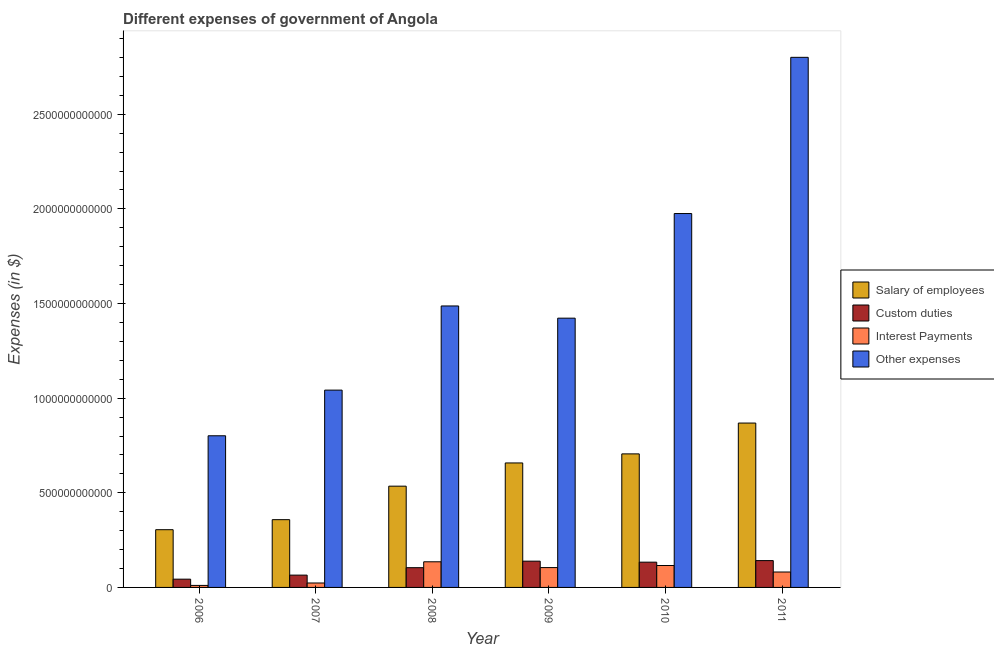How many different coloured bars are there?
Offer a very short reply. 4. Are the number of bars per tick equal to the number of legend labels?
Your answer should be very brief. Yes. Are the number of bars on each tick of the X-axis equal?
Your answer should be very brief. Yes. How many bars are there on the 6th tick from the left?
Provide a succinct answer. 4. What is the amount spent on other expenses in 2010?
Keep it short and to the point. 1.98e+12. Across all years, what is the maximum amount spent on custom duties?
Keep it short and to the point. 1.42e+11. Across all years, what is the minimum amount spent on other expenses?
Offer a very short reply. 8.01e+11. In which year was the amount spent on interest payments maximum?
Offer a terse response. 2008. What is the total amount spent on custom duties in the graph?
Offer a terse response. 6.27e+11. What is the difference between the amount spent on interest payments in 2006 and that in 2011?
Make the answer very short. -7.08e+1. What is the difference between the amount spent on other expenses in 2010 and the amount spent on custom duties in 2007?
Ensure brevity in your answer.  9.33e+11. What is the average amount spent on custom duties per year?
Make the answer very short. 1.04e+11. In how many years, is the amount spent on other expenses greater than 2100000000000 $?
Provide a short and direct response. 1. What is the ratio of the amount spent on interest payments in 2006 to that in 2009?
Your response must be concise. 0.1. Is the amount spent on custom duties in 2006 less than that in 2011?
Provide a succinct answer. Yes. What is the difference between the highest and the second highest amount spent on salary of employees?
Keep it short and to the point. 1.63e+11. What is the difference between the highest and the lowest amount spent on custom duties?
Make the answer very short. 9.81e+1. In how many years, is the amount spent on custom duties greater than the average amount spent on custom duties taken over all years?
Give a very brief answer. 3. Is the sum of the amount spent on custom duties in 2006 and 2007 greater than the maximum amount spent on other expenses across all years?
Provide a succinct answer. No. Is it the case that in every year, the sum of the amount spent on custom duties and amount spent on salary of employees is greater than the sum of amount spent on other expenses and amount spent on interest payments?
Make the answer very short. No. What does the 3rd bar from the left in 2006 represents?
Give a very brief answer. Interest Payments. What does the 2nd bar from the right in 2006 represents?
Ensure brevity in your answer.  Interest Payments. Is it the case that in every year, the sum of the amount spent on salary of employees and amount spent on custom duties is greater than the amount spent on interest payments?
Your response must be concise. Yes. How many bars are there?
Provide a short and direct response. 24. Are all the bars in the graph horizontal?
Ensure brevity in your answer.  No. What is the difference between two consecutive major ticks on the Y-axis?
Make the answer very short. 5.00e+11. Are the values on the major ticks of Y-axis written in scientific E-notation?
Your answer should be compact. No. Does the graph contain any zero values?
Provide a short and direct response. No. Where does the legend appear in the graph?
Provide a short and direct response. Center right. How are the legend labels stacked?
Keep it short and to the point. Vertical. What is the title of the graph?
Your answer should be compact. Different expenses of government of Angola. Does "UNDP" appear as one of the legend labels in the graph?
Offer a very short reply. No. What is the label or title of the Y-axis?
Your answer should be compact. Expenses (in $). What is the Expenses (in $) in Salary of employees in 2006?
Give a very brief answer. 3.05e+11. What is the Expenses (in $) in Custom duties in 2006?
Ensure brevity in your answer.  4.37e+1. What is the Expenses (in $) of Interest Payments in 2006?
Make the answer very short. 1.07e+1. What is the Expenses (in $) of Other expenses in 2006?
Keep it short and to the point. 8.01e+11. What is the Expenses (in $) in Salary of employees in 2007?
Offer a very short reply. 3.58e+11. What is the Expenses (in $) in Custom duties in 2007?
Ensure brevity in your answer.  6.50e+1. What is the Expenses (in $) of Interest Payments in 2007?
Keep it short and to the point. 2.35e+1. What is the Expenses (in $) of Other expenses in 2007?
Your answer should be compact. 1.04e+12. What is the Expenses (in $) of Salary of employees in 2008?
Offer a terse response. 5.35e+11. What is the Expenses (in $) in Custom duties in 2008?
Your answer should be compact. 1.04e+11. What is the Expenses (in $) of Interest Payments in 2008?
Your answer should be compact. 1.35e+11. What is the Expenses (in $) of Other expenses in 2008?
Your answer should be compact. 1.49e+12. What is the Expenses (in $) in Salary of employees in 2009?
Offer a terse response. 6.58e+11. What is the Expenses (in $) of Custom duties in 2009?
Offer a terse response. 1.39e+11. What is the Expenses (in $) in Interest Payments in 2009?
Your answer should be very brief. 1.05e+11. What is the Expenses (in $) in Other expenses in 2009?
Ensure brevity in your answer.  1.42e+12. What is the Expenses (in $) in Salary of employees in 2010?
Keep it short and to the point. 7.06e+11. What is the Expenses (in $) of Custom duties in 2010?
Make the answer very short. 1.33e+11. What is the Expenses (in $) of Interest Payments in 2010?
Give a very brief answer. 1.16e+11. What is the Expenses (in $) of Other expenses in 2010?
Keep it short and to the point. 1.98e+12. What is the Expenses (in $) in Salary of employees in 2011?
Offer a very short reply. 8.68e+11. What is the Expenses (in $) of Custom duties in 2011?
Your answer should be very brief. 1.42e+11. What is the Expenses (in $) of Interest Payments in 2011?
Give a very brief answer. 8.15e+1. What is the Expenses (in $) in Other expenses in 2011?
Provide a short and direct response. 2.80e+12. Across all years, what is the maximum Expenses (in $) in Salary of employees?
Provide a succinct answer. 8.68e+11. Across all years, what is the maximum Expenses (in $) of Custom duties?
Offer a very short reply. 1.42e+11. Across all years, what is the maximum Expenses (in $) of Interest Payments?
Keep it short and to the point. 1.35e+11. Across all years, what is the maximum Expenses (in $) in Other expenses?
Give a very brief answer. 2.80e+12. Across all years, what is the minimum Expenses (in $) of Salary of employees?
Make the answer very short. 3.05e+11. Across all years, what is the minimum Expenses (in $) of Custom duties?
Your response must be concise. 4.37e+1. Across all years, what is the minimum Expenses (in $) in Interest Payments?
Keep it short and to the point. 1.07e+1. Across all years, what is the minimum Expenses (in $) in Other expenses?
Provide a short and direct response. 8.01e+11. What is the total Expenses (in $) in Salary of employees in the graph?
Provide a short and direct response. 3.43e+12. What is the total Expenses (in $) in Custom duties in the graph?
Your answer should be very brief. 6.27e+11. What is the total Expenses (in $) in Interest Payments in the graph?
Your answer should be very brief. 4.72e+11. What is the total Expenses (in $) of Other expenses in the graph?
Offer a very short reply. 9.53e+12. What is the difference between the Expenses (in $) in Salary of employees in 2006 and that in 2007?
Your response must be concise. -5.30e+1. What is the difference between the Expenses (in $) of Custom duties in 2006 and that in 2007?
Ensure brevity in your answer.  -2.13e+1. What is the difference between the Expenses (in $) of Interest Payments in 2006 and that in 2007?
Ensure brevity in your answer.  -1.28e+1. What is the difference between the Expenses (in $) in Other expenses in 2006 and that in 2007?
Your answer should be very brief. -2.41e+11. What is the difference between the Expenses (in $) in Salary of employees in 2006 and that in 2008?
Your answer should be compact. -2.30e+11. What is the difference between the Expenses (in $) of Custom duties in 2006 and that in 2008?
Give a very brief answer. -6.06e+1. What is the difference between the Expenses (in $) of Interest Payments in 2006 and that in 2008?
Your answer should be very brief. -1.25e+11. What is the difference between the Expenses (in $) in Other expenses in 2006 and that in 2008?
Your answer should be compact. -6.86e+11. What is the difference between the Expenses (in $) of Salary of employees in 2006 and that in 2009?
Provide a succinct answer. -3.53e+11. What is the difference between the Expenses (in $) of Custom duties in 2006 and that in 2009?
Make the answer very short. -9.51e+1. What is the difference between the Expenses (in $) of Interest Payments in 2006 and that in 2009?
Your response must be concise. -9.41e+1. What is the difference between the Expenses (in $) in Other expenses in 2006 and that in 2009?
Give a very brief answer. -6.21e+11. What is the difference between the Expenses (in $) of Salary of employees in 2006 and that in 2010?
Keep it short and to the point. -4.01e+11. What is the difference between the Expenses (in $) in Custom duties in 2006 and that in 2010?
Your response must be concise. -8.98e+1. What is the difference between the Expenses (in $) of Interest Payments in 2006 and that in 2010?
Your answer should be compact. -1.05e+11. What is the difference between the Expenses (in $) in Other expenses in 2006 and that in 2010?
Ensure brevity in your answer.  -1.17e+12. What is the difference between the Expenses (in $) of Salary of employees in 2006 and that in 2011?
Your answer should be compact. -5.63e+11. What is the difference between the Expenses (in $) in Custom duties in 2006 and that in 2011?
Your response must be concise. -9.81e+1. What is the difference between the Expenses (in $) of Interest Payments in 2006 and that in 2011?
Ensure brevity in your answer.  -7.08e+1. What is the difference between the Expenses (in $) of Other expenses in 2006 and that in 2011?
Offer a terse response. -2.00e+12. What is the difference between the Expenses (in $) in Salary of employees in 2007 and that in 2008?
Provide a succinct answer. -1.77e+11. What is the difference between the Expenses (in $) of Custom duties in 2007 and that in 2008?
Your answer should be very brief. -3.93e+1. What is the difference between the Expenses (in $) in Interest Payments in 2007 and that in 2008?
Your answer should be compact. -1.12e+11. What is the difference between the Expenses (in $) of Other expenses in 2007 and that in 2008?
Offer a terse response. -4.45e+11. What is the difference between the Expenses (in $) in Salary of employees in 2007 and that in 2009?
Offer a terse response. -3.00e+11. What is the difference between the Expenses (in $) of Custom duties in 2007 and that in 2009?
Provide a short and direct response. -7.38e+1. What is the difference between the Expenses (in $) of Interest Payments in 2007 and that in 2009?
Offer a terse response. -8.13e+1. What is the difference between the Expenses (in $) of Other expenses in 2007 and that in 2009?
Offer a terse response. -3.80e+11. What is the difference between the Expenses (in $) of Salary of employees in 2007 and that in 2010?
Your answer should be very brief. -3.48e+11. What is the difference between the Expenses (in $) of Custom duties in 2007 and that in 2010?
Your answer should be compact. -6.84e+1. What is the difference between the Expenses (in $) of Interest Payments in 2007 and that in 2010?
Give a very brief answer. -9.24e+1. What is the difference between the Expenses (in $) of Other expenses in 2007 and that in 2010?
Provide a short and direct response. -9.33e+11. What is the difference between the Expenses (in $) in Salary of employees in 2007 and that in 2011?
Your answer should be very brief. -5.10e+11. What is the difference between the Expenses (in $) in Custom duties in 2007 and that in 2011?
Your answer should be very brief. -7.67e+1. What is the difference between the Expenses (in $) of Interest Payments in 2007 and that in 2011?
Keep it short and to the point. -5.80e+1. What is the difference between the Expenses (in $) of Other expenses in 2007 and that in 2011?
Make the answer very short. -1.76e+12. What is the difference between the Expenses (in $) in Salary of employees in 2008 and that in 2009?
Your answer should be very brief. -1.23e+11. What is the difference between the Expenses (in $) of Custom duties in 2008 and that in 2009?
Ensure brevity in your answer.  -3.45e+1. What is the difference between the Expenses (in $) in Interest Payments in 2008 and that in 2009?
Your answer should be compact. 3.07e+1. What is the difference between the Expenses (in $) of Other expenses in 2008 and that in 2009?
Provide a succinct answer. 6.45e+1. What is the difference between the Expenses (in $) in Salary of employees in 2008 and that in 2010?
Provide a succinct answer. -1.71e+11. What is the difference between the Expenses (in $) of Custom duties in 2008 and that in 2010?
Keep it short and to the point. -2.92e+1. What is the difference between the Expenses (in $) in Interest Payments in 2008 and that in 2010?
Your answer should be very brief. 1.96e+1. What is the difference between the Expenses (in $) in Other expenses in 2008 and that in 2010?
Ensure brevity in your answer.  -4.88e+11. What is the difference between the Expenses (in $) in Salary of employees in 2008 and that in 2011?
Offer a terse response. -3.33e+11. What is the difference between the Expenses (in $) in Custom duties in 2008 and that in 2011?
Offer a very short reply. -3.74e+1. What is the difference between the Expenses (in $) in Interest Payments in 2008 and that in 2011?
Ensure brevity in your answer.  5.40e+1. What is the difference between the Expenses (in $) in Other expenses in 2008 and that in 2011?
Offer a very short reply. -1.31e+12. What is the difference between the Expenses (in $) in Salary of employees in 2009 and that in 2010?
Offer a very short reply. -4.79e+1. What is the difference between the Expenses (in $) in Custom duties in 2009 and that in 2010?
Provide a succinct answer. 5.33e+09. What is the difference between the Expenses (in $) in Interest Payments in 2009 and that in 2010?
Offer a terse response. -1.10e+1. What is the difference between the Expenses (in $) in Other expenses in 2009 and that in 2010?
Ensure brevity in your answer.  -5.53e+11. What is the difference between the Expenses (in $) in Salary of employees in 2009 and that in 2011?
Ensure brevity in your answer.  -2.11e+11. What is the difference between the Expenses (in $) of Custom duties in 2009 and that in 2011?
Keep it short and to the point. -2.95e+09. What is the difference between the Expenses (in $) of Interest Payments in 2009 and that in 2011?
Ensure brevity in your answer.  2.33e+1. What is the difference between the Expenses (in $) of Other expenses in 2009 and that in 2011?
Offer a very short reply. -1.38e+12. What is the difference between the Expenses (in $) of Salary of employees in 2010 and that in 2011?
Make the answer very short. -1.63e+11. What is the difference between the Expenses (in $) of Custom duties in 2010 and that in 2011?
Offer a very short reply. -8.27e+09. What is the difference between the Expenses (in $) of Interest Payments in 2010 and that in 2011?
Your answer should be very brief. 3.44e+1. What is the difference between the Expenses (in $) in Other expenses in 2010 and that in 2011?
Keep it short and to the point. -8.25e+11. What is the difference between the Expenses (in $) in Salary of employees in 2006 and the Expenses (in $) in Custom duties in 2007?
Your answer should be very brief. 2.40e+11. What is the difference between the Expenses (in $) of Salary of employees in 2006 and the Expenses (in $) of Interest Payments in 2007?
Ensure brevity in your answer.  2.82e+11. What is the difference between the Expenses (in $) of Salary of employees in 2006 and the Expenses (in $) of Other expenses in 2007?
Ensure brevity in your answer.  -7.37e+11. What is the difference between the Expenses (in $) of Custom duties in 2006 and the Expenses (in $) of Interest Payments in 2007?
Provide a short and direct response. 2.02e+1. What is the difference between the Expenses (in $) in Custom duties in 2006 and the Expenses (in $) in Other expenses in 2007?
Your answer should be very brief. -9.99e+11. What is the difference between the Expenses (in $) of Interest Payments in 2006 and the Expenses (in $) of Other expenses in 2007?
Make the answer very short. -1.03e+12. What is the difference between the Expenses (in $) of Salary of employees in 2006 and the Expenses (in $) of Custom duties in 2008?
Your answer should be very brief. 2.01e+11. What is the difference between the Expenses (in $) of Salary of employees in 2006 and the Expenses (in $) of Interest Payments in 2008?
Provide a short and direct response. 1.70e+11. What is the difference between the Expenses (in $) in Salary of employees in 2006 and the Expenses (in $) in Other expenses in 2008?
Offer a terse response. -1.18e+12. What is the difference between the Expenses (in $) in Custom duties in 2006 and the Expenses (in $) in Interest Payments in 2008?
Provide a succinct answer. -9.18e+1. What is the difference between the Expenses (in $) of Custom duties in 2006 and the Expenses (in $) of Other expenses in 2008?
Provide a short and direct response. -1.44e+12. What is the difference between the Expenses (in $) of Interest Payments in 2006 and the Expenses (in $) of Other expenses in 2008?
Provide a short and direct response. -1.48e+12. What is the difference between the Expenses (in $) in Salary of employees in 2006 and the Expenses (in $) in Custom duties in 2009?
Ensure brevity in your answer.  1.66e+11. What is the difference between the Expenses (in $) of Salary of employees in 2006 and the Expenses (in $) of Interest Payments in 2009?
Make the answer very short. 2.00e+11. What is the difference between the Expenses (in $) in Salary of employees in 2006 and the Expenses (in $) in Other expenses in 2009?
Ensure brevity in your answer.  -1.12e+12. What is the difference between the Expenses (in $) in Custom duties in 2006 and the Expenses (in $) in Interest Payments in 2009?
Ensure brevity in your answer.  -6.11e+1. What is the difference between the Expenses (in $) in Custom duties in 2006 and the Expenses (in $) in Other expenses in 2009?
Ensure brevity in your answer.  -1.38e+12. What is the difference between the Expenses (in $) in Interest Payments in 2006 and the Expenses (in $) in Other expenses in 2009?
Your answer should be very brief. -1.41e+12. What is the difference between the Expenses (in $) in Salary of employees in 2006 and the Expenses (in $) in Custom duties in 2010?
Your answer should be compact. 1.72e+11. What is the difference between the Expenses (in $) in Salary of employees in 2006 and the Expenses (in $) in Interest Payments in 2010?
Give a very brief answer. 1.89e+11. What is the difference between the Expenses (in $) in Salary of employees in 2006 and the Expenses (in $) in Other expenses in 2010?
Provide a short and direct response. -1.67e+12. What is the difference between the Expenses (in $) of Custom duties in 2006 and the Expenses (in $) of Interest Payments in 2010?
Your answer should be very brief. -7.22e+1. What is the difference between the Expenses (in $) in Custom duties in 2006 and the Expenses (in $) in Other expenses in 2010?
Make the answer very short. -1.93e+12. What is the difference between the Expenses (in $) of Interest Payments in 2006 and the Expenses (in $) of Other expenses in 2010?
Provide a short and direct response. -1.96e+12. What is the difference between the Expenses (in $) in Salary of employees in 2006 and the Expenses (in $) in Custom duties in 2011?
Your answer should be very brief. 1.63e+11. What is the difference between the Expenses (in $) of Salary of employees in 2006 and the Expenses (in $) of Interest Payments in 2011?
Ensure brevity in your answer.  2.24e+11. What is the difference between the Expenses (in $) of Salary of employees in 2006 and the Expenses (in $) of Other expenses in 2011?
Keep it short and to the point. -2.50e+12. What is the difference between the Expenses (in $) of Custom duties in 2006 and the Expenses (in $) of Interest Payments in 2011?
Your answer should be very brief. -3.78e+1. What is the difference between the Expenses (in $) of Custom duties in 2006 and the Expenses (in $) of Other expenses in 2011?
Your answer should be very brief. -2.76e+12. What is the difference between the Expenses (in $) in Interest Payments in 2006 and the Expenses (in $) in Other expenses in 2011?
Keep it short and to the point. -2.79e+12. What is the difference between the Expenses (in $) in Salary of employees in 2007 and the Expenses (in $) in Custom duties in 2008?
Provide a succinct answer. 2.54e+11. What is the difference between the Expenses (in $) in Salary of employees in 2007 and the Expenses (in $) in Interest Payments in 2008?
Keep it short and to the point. 2.23e+11. What is the difference between the Expenses (in $) of Salary of employees in 2007 and the Expenses (in $) of Other expenses in 2008?
Provide a short and direct response. -1.13e+12. What is the difference between the Expenses (in $) of Custom duties in 2007 and the Expenses (in $) of Interest Payments in 2008?
Offer a very short reply. -7.05e+1. What is the difference between the Expenses (in $) of Custom duties in 2007 and the Expenses (in $) of Other expenses in 2008?
Make the answer very short. -1.42e+12. What is the difference between the Expenses (in $) in Interest Payments in 2007 and the Expenses (in $) in Other expenses in 2008?
Offer a very short reply. -1.46e+12. What is the difference between the Expenses (in $) of Salary of employees in 2007 and the Expenses (in $) of Custom duties in 2009?
Keep it short and to the point. 2.19e+11. What is the difference between the Expenses (in $) in Salary of employees in 2007 and the Expenses (in $) in Interest Payments in 2009?
Provide a succinct answer. 2.53e+11. What is the difference between the Expenses (in $) in Salary of employees in 2007 and the Expenses (in $) in Other expenses in 2009?
Your answer should be compact. -1.06e+12. What is the difference between the Expenses (in $) of Custom duties in 2007 and the Expenses (in $) of Interest Payments in 2009?
Offer a terse response. -3.98e+1. What is the difference between the Expenses (in $) in Custom duties in 2007 and the Expenses (in $) in Other expenses in 2009?
Make the answer very short. -1.36e+12. What is the difference between the Expenses (in $) of Interest Payments in 2007 and the Expenses (in $) of Other expenses in 2009?
Keep it short and to the point. -1.40e+12. What is the difference between the Expenses (in $) in Salary of employees in 2007 and the Expenses (in $) in Custom duties in 2010?
Keep it short and to the point. 2.25e+11. What is the difference between the Expenses (in $) in Salary of employees in 2007 and the Expenses (in $) in Interest Payments in 2010?
Keep it short and to the point. 2.42e+11. What is the difference between the Expenses (in $) of Salary of employees in 2007 and the Expenses (in $) of Other expenses in 2010?
Offer a very short reply. -1.62e+12. What is the difference between the Expenses (in $) in Custom duties in 2007 and the Expenses (in $) in Interest Payments in 2010?
Offer a very short reply. -5.08e+1. What is the difference between the Expenses (in $) of Custom duties in 2007 and the Expenses (in $) of Other expenses in 2010?
Your answer should be compact. -1.91e+12. What is the difference between the Expenses (in $) of Interest Payments in 2007 and the Expenses (in $) of Other expenses in 2010?
Offer a very short reply. -1.95e+12. What is the difference between the Expenses (in $) of Salary of employees in 2007 and the Expenses (in $) of Custom duties in 2011?
Offer a very short reply. 2.16e+11. What is the difference between the Expenses (in $) in Salary of employees in 2007 and the Expenses (in $) in Interest Payments in 2011?
Offer a very short reply. 2.77e+11. What is the difference between the Expenses (in $) of Salary of employees in 2007 and the Expenses (in $) of Other expenses in 2011?
Your response must be concise. -2.44e+12. What is the difference between the Expenses (in $) in Custom duties in 2007 and the Expenses (in $) in Interest Payments in 2011?
Keep it short and to the point. -1.64e+1. What is the difference between the Expenses (in $) in Custom duties in 2007 and the Expenses (in $) in Other expenses in 2011?
Make the answer very short. -2.74e+12. What is the difference between the Expenses (in $) of Interest Payments in 2007 and the Expenses (in $) of Other expenses in 2011?
Your answer should be compact. -2.78e+12. What is the difference between the Expenses (in $) in Salary of employees in 2008 and the Expenses (in $) in Custom duties in 2009?
Provide a succinct answer. 3.96e+11. What is the difference between the Expenses (in $) in Salary of employees in 2008 and the Expenses (in $) in Interest Payments in 2009?
Give a very brief answer. 4.30e+11. What is the difference between the Expenses (in $) of Salary of employees in 2008 and the Expenses (in $) of Other expenses in 2009?
Keep it short and to the point. -8.88e+11. What is the difference between the Expenses (in $) of Custom duties in 2008 and the Expenses (in $) of Interest Payments in 2009?
Give a very brief answer. -5.00e+08. What is the difference between the Expenses (in $) in Custom duties in 2008 and the Expenses (in $) in Other expenses in 2009?
Offer a terse response. -1.32e+12. What is the difference between the Expenses (in $) of Interest Payments in 2008 and the Expenses (in $) of Other expenses in 2009?
Offer a very short reply. -1.29e+12. What is the difference between the Expenses (in $) in Salary of employees in 2008 and the Expenses (in $) in Custom duties in 2010?
Offer a very short reply. 4.02e+11. What is the difference between the Expenses (in $) in Salary of employees in 2008 and the Expenses (in $) in Interest Payments in 2010?
Keep it short and to the point. 4.19e+11. What is the difference between the Expenses (in $) of Salary of employees in 2008 and the Expenses (in $) of Other expenses in 2010?
Your answer should be compact. -1.44e+12. What is the difference between the Expenses (in $) in Custom duties in 2008 and the Expenses (in $) in Interest Payments in 2010?
Your answer should be compact. -1.15e+1. What is the difference between the Expenses (in $) in Custom duties in 2008 and the Expenses (in $) in Other expenses in 2010?
Your answer should be very brief. -1.87e+12. What is the difference between the Expenses (in $) of Interest Payments in 2008 and the Expenses (in $) of Other expenses in 2010?
Provide a short and direct response. -1.84e+12. What is the difference between the Expenses (in $) in Salary of employees in 2008 and the Expenses (in $) in Custom duties in 2011?
Keep it short and to the point. 3.93e+11. What is the difference between the Expenses (in $) of Salary of employees in 2008 and the Expenses (in $) of Interest Payments in 2011?
Provide a succinct answer. 4.54e+11. What is the difference between the Expenses (in $) of Salary of employees in 2008 and the Expenses (in $) of Other expenses in 2011?
Keep it short and to the point. -2.27e+12. What is the difference between the Expenses (in $) in Custom duties in 2008 and the Expenses (in $) in Interest Payments in 2011?
Keep it short and to the point. 2.28e+1. What is the difference between the Expenses (in $) in Custom duties in 2008 and the Expenses (in $) in Other expenses in 2011?
Provide a short and direct response. -2.70e+12. What is the difference between the Expenses (in $) of Interest Payments in 2008 and the Expenses (in $) of Other expenses in 2011?
Keep it short and to the point. -2.67e+12. What is the difference between the Expenses (in $) of Salary of employees in 2009 and the Expenses (in $) of Custom duties in 2010?
Your answer should be very brief. 5.24e+11. What is the difference between the Expenses (in $) of Salary of employees in 2009 and the Expenses (in $) of Interest Payments in 2010?
Your response must be concise. 5.42e+11. What is the difference between the Expenses (in $) of Salary of employees in 2009 and the Expenses (in $) of Other expenses in 2010?
Keep it short and to the point. -1.32e+12. What is the difference between the Expenses (in $) in Custom duties in 2009 and the Expenses (in $) in Interest Payments in 2010?
Ensure brevity in your answer.  2.29e+1. What is the difference between the Expenses (in $) of Custom duties in 2009 and the Expenses (in $) of Other expenses in 2010?
Keep it short and to the point. -1.84e+12. What is the difference between the Expenses (in $) in Interest Payments in 2009 and the Expenses (in $) in Other expenses in 2010?
Make the answer very short. -1.87e+12. What is the difference between the Expenses (in $) of Salary of employees in 2009 and the Expenses (in $) of Custom duties in 2011?
Offer a very short reply. 5.16e+11. What is the difference between the Expenses (in $) in Salary of employees in 2009 and the Expenses (in $) in Interest Payments in 2011?
Your response must be concise. 5.76e+11. What is the difference between the Expenses (in $) of Salary of employees in 2009 and the Expenses (in $) of Other expenses in 2011?
Keep it short and to the point. -2.14e+12. What is the difference between the Expenses (in $) of Custom duties in 2009 and the Expenses (in $) of Interest Payments in 2011?
Offer a terse response. 5.73e+1. What is the difference between the Expenses (in $) of Custom duties in 2009 and the Expenses (in $) of Other expenses in 2011?
Your answer should be compact. -2.66e+12. What is the difference between the Expenses (in $) in Interest Payments in 2009 and the Expenses (in $) in Other expenses in 2011?
Offer a very short reply. -2.70e+12. What is the difference between the Expenses (in $) of Salary of employees in 2010 and the Expenses (in $) of Custom duties in 2011?
Ensure brevity in your answer.  5.64e+11. What is the difference between the Expenses (in $) in Salary of employees in 2010 and the Expenses (in $) in Interest Payments in 2011?
Make the answer very short. 6.24e+11. What is the difference between the Expenses (in $) in Salary of employees in 2010 and the Expenses (in $) in Other expenses in 2011?
Your answer should be very brief. -2.10e+12. What is the difference between the Expenses (in $) of Custom duties in 2010 and the Expenses (in $) of Interest Payments in 2011?
Your answer should be very brief. 5.20e+1. What is the difference between the Expenses (in $) in Custom duties in 2010 and the Expenses (in $) in Other expenses in 2011?
Make the answer very short. -2.67e+12. What is the difference between the Expenses (in $) of Interest Payments in 2010 and the Expenses (in $) of Other expenses in 2011?
Offer a very short reply. -2.68e+12. What is the average Expenses (in $) in Salary of employees per year?
Your response must be concise. 5.72e+11. What is the average Expenses (in $) of Custom duties per year?
Make the answer very short. 1.04e+11. What is the average Expenses (in $) of Interest Payments per year?
Your response must be concise. 7.86e+1. What is the average Expenses (in $) of Other expenses per year?
Offer a terse response. 1.59e+12. In the year 2006, what is the difference between the Expenses (in $) of Salary of employees and Expenses (in $) of Custom duties?
Give a very brief answer. 2.61e+11. In the year 2006, what is the difference between the Expenses (in $) in Salary of employees and Expenses (in $) in Interest Payments?
Ensure brevity in your answer.  2.94e+11. In the year 2006, what is the difference between the Expenses (in $) in Salary of employees and Expenses (in $) in Other expenses?
Your answer should be compact. -4.96e+11. In the year 2006, what is the difference between the Expenses (in $) of Custom duties and Expenses (in $) of Interest Payments?
Your response must be concise. 3.30e+1. In the year 2006, what is the difference between the Expenses (in $) of Custom duties and Expenses (in $) of Other expenses?
Ensure brevity in your answer.  -7.58e+11. In the year 2006, what is the difference between the Expenses (in $) in Interest Payments and Expenses (in $) in Other expenses?
Give a very brief answer. -7.91e+11. In the year 2007, what is the difference between the Expenses (in $) of Salary of employees and Expenses (in $) of Custom duties?
Give a very brief answer. 2.93e+11. In the year 2007, what is the difference between the Expenses (in $) in Salary of employees and Expenses (in $) in Interest Payments?
Your answer should be very brief. 3.35e+11. In the year 2007, what is the difference between the Expenses (in $) in Salary of employees and Expenses (in $) in Other expenses?
Make the answer very short. -6.84e+11. In the year 2007, what is the difference between the Expenses (in $) of Custom duties and Expenses (in $) of Interest Payments?
Give a very brief answer. 4.15e+1. In the year 2007, what is the difference between the Expenses (in $) of Custom duties and Expenses (in $) of Other expenses?
Your response must be concise. -9.77e+11. In the year 2007, what is the difference between the Expenses (in $) in Interest Payments and Expenses (in $) in Other expenses?
Your answer should be compact. -1.02e+12. In the year 2008, what is the difference between the Expenses (in $) in Salary of employees and Expenses (in $) in Custom duties?
Make the answer very short. 4.31e+11. In the year 2008, what is the difference between the Expenses (in $) of Salary of employees and Expenses (in $) of Interest Payments?
Keep it short and to the point. 4.00e+11. In the year 2008, what is the difference between the Expenses (in $) in Salary of employees and Expenses (in $) in Other expenses?
Provide a short and direct response. -9.52e+11. In the year 2008, what is the difference between the Expenses (in $) of Custom duties and Expenses (in $) of Interest Payments?
Make the answer very short. -3.12e+1. In the year 2008, what is the difference between the Expenses (in $) in Custom duties and Expenses (in $) in Other expenses?
Keep it short and to the point. -1.38e+12. In the year 2008, what is the difference between the Expenses (in $) in Interest Payments and Expenses (in $) in Other expenses?
Offer a very short reply. -1.35e+12. In the year 2009, what is the difference between the Expenses (in $) in Salary of employees and Expenses (in $) in Custom duties?
Offer a terse response. 5.19e+11. In the year 2009, what is the difference between the Expenses (in $) of Salary of employees and Expenses (in $) of Interest Payments?
Offer a very short reply. 5.53e+11. In the year 2009, what is the difference between the Expenses (in $) of Salary of employees and Expenses (in $) of Other expenses?
Provide a short and direct response. -7.65e+11. In the year 2009, what is the difference between the Expenses (in $) in Custom duties and Expenses (in $) in Interest Payments?
Your response must be concise. 3.40e+1. In the year 2009, what is the difference between the Expenses (in $) in Custom duties and Expenses (in $) in Other expenses?
Provide a succinct answer. -1.28e+12. In the year 2009, what is the difference between the Expenses (in $) in Interest Payments and Expenses (in $) in Other expenses?
Provide a succinct answer. -1.32e+12. In the year 2010, what is the difference between the Expenses (in $) in Salary of employees and Expenses (in $) in Custom duties?
Ensure brevity in your answer.  5.72e+11. In the year 2010, what is the difference between the Expenses (in $) of Salary of employees and Expenses (in $) of Interest Payments?
Offer a terse response. 5.90e+11. In the year 2010, what is the difference between the Expenses (in $) of Salary of employees and Expenses (in $) of Other expenses?
Your answer should be compact. -1.27e+12. In the year 2010, what is the difference between the Expenses (in $) of Custom duties and Expenses (in $) of Interest Payments?
Give a very brief answer. 1.76e+1. In the year 2010, what is the difference between the Expenses (in $) of Custom duties and Expenses (in $) of Other expenses?
Your answer should be compact. -1.84e+12. In the year 2010, what is the difference between the Expenses (in $) in Interest Payments and Expenses (in $) in Other expenses?
Offer a terse response. -1.86e+12. In the year 2011, what is the difference between the Expenses (in $) in Salary of employees and Expenses (in $) in Custom duties?
Ensure brevity in your answer.  7.27e+11. In the year 2011, what is the difference between the Expenses (in $) in Salary of employees and Expenses (in $) in Interest Payments?
Keep it short and to the point. 7.87e+11. In the year 2011, what is the difference between the Expenses (in $) in Salary of employees and Expenses (in $) in Other expenses?
Provide a short and direct response. -1.93e+12. In the year 2011, what is the difference between the Expenses (in $) of Custom duties and Expenses (in $) of Interest Payments?
Ensure brevity in your answer.  6.03e+1. In the year 2011, what is the difference between the Expenses (in $) in Custom duties and Expenses (in $) in Other expenses?
Ensure brevity in your answer.  -2.66e+12. In the year 2011, what is the difference between the Expenses (in $) of Interest Payments and Expenses (in $) of Other expenses?
Your answer should be compact. -2.72e+12. What is the ratio of the Expenses (in $) of Salary of employees in 2006 to that in 2007?
Offer a very short reply. 0.85. What is the ratio of the Expenses (in $) of Custom duties in 2006 to that in 2007?
Give a very brief answer. 0.67. What is the ratio of the Expenses (in $) of Interest Payments in 2006 to that in 2007?
Your response must be concise. 0.45. What is the ratio of the Expenses (in $) in Other expenses in 2006 to that in 2007?
Make the answer very short. 0.77. What is the ratio of the Expenses (in $) in Salary of employees in 2006 to that in 2008?
Keep it short and to the point. 0.57. What is the ratio of the Expenses (in $) of Custom duties in 2006 to that in 2008?
Give a very brief answer. 0.42. What is the ratio of the Expenses (in $) in Interest Payments in 2006 to that in 2008?
Your answer should be compact. 0.08. What is the ratio of the Expenses (in $) in Other expenses in 2006 to that in 2008?
Provide a short and direct response. 0.54. What is the ratio of the Expenses (in $) in Salary of employees in 2006 to that in 2009?
Ensure brevity in your answer.  0.46. What is the ratio of the Expenses (in $) in Custom duties in 2006 to that in 2009?
Provide a short and direct response. 0.31. What is the ratio of the Expenses (in $) in Interest Payments in 2006 to that in 2009?
Your response must be concise. 0.1. What is the ratio of the Expenses (in $) of Other expenses in 2006 to that in 2009?
Make the answer very short. 0.56. What is the ratio of the Expenses (in $) in Salary of employees in 2006 to that in 2010?
Offer a terse response. 0.43. What is the ratio of the Expenses (in $) of Custom duties in 2006 to that in 2010?
Provide a short and direct response. 0.33. What is the ratio of the Expenses (in $) of Interest Payments in 2006 to that in 2010?
Offer a very short reply. 0.09. What is the ratio of the Expenses (in $) in Other expenses in 2006 to that in 2010?
Give a very brief answer. 0.41. What is the ratio of the Expenses (in $) in Salary of employees in 2006 to that in 2011?
Your response must be concise. 0.35. What is the ratio of the Expenses (in $) in Custom duties in 2006 to that in 2011?
Provide a short and direct response. 0.31. What is the ratio of the Expenses (in $) of Interest Payments in 2006 to that in 2011?
Give a very brief answer. 0.13. What is the ratio of the Expenses (in $) in Other expenses in 2006 to that in 2011?
Your answer should be compact. 0.29. What is the ratio of the Expenses (in $) of Salary of employees in 2007 to that in 2008?
Your response must be concise. 0.67. What is the ratio of the Expenses (in $) of Custom duties in 2007 to that in 2008?
Your answer should be compact. 0.62. What is the ratio of the Expenses (in $) in Interest Payments in 2007 to that in 2008?
Provide a short and direct response. 0.17. What is the ratio of the Expenses (in $) in Other expenses in 2007 to that in 2008?
Your answer should be very brief. 0.7. What is the ratio of the Expenses (in $) in Salary of employees in 2007 to that in 2009?
Offer a terse response. 0.54. What is the ratio of the Expenses (in $) of Custom duties in 2007 to that in 2009?
Your answer should be compact. 0.47. What is the ratio of the Expenses (in $) of Interest Payments in 2007 to that in 2009?
Your response must be concise. 0.22. What is the ratio of the Expenses (in $) in Other expenses in 2007 to that in 2009?
Your answer should be very brief. 0.73. What is the ratio of the Expenses (in $) in Salary of employees in 2007 to that in 2010?
Make the answer very short. 0.51. What is the ratio of the Expenses (in $) of Custom duties in 2007 to that in 2010?
Offer a terse response. 0.49. What is the ratio of the Expenses (in $) in Interest Payments in 2007 to that in 2010?
Offer a terse response. 0.2. What is the ratio of the Expenses (in $) in Other expenses in 2007 to that in 2010?
Your answer should be very brief. 0.53. What is the ratio of the Expenses (in $) in Salary of employees in 2007 to that in 2011?
Your response must be concise. 0.41. What is the ratio of the Expenses (in $) in Custom duties in 2007 to that in 2011?
Your response must be concise. 0.46. What is the ratio of the Expenses (in $) in Interest Payments in 2007 to that in 2011?
Your answer should be very brief. 0.29. What is the ratio of the Expenses (in $) of Other expenses in 2007 to that in 2011?
Give a very brief answer. 0.37. What is the ratio of the Expenses (in $) in Salary of employees in 2008 to that in 2009?
Give a very brief answer. 0.81. What is the ratio of the Expenses (in $) of Custom duties in 2008 to that in 2009?
Offer a very short reply. 0.75. What is the ratio of the Expenses (in $) in Interest Payments in 2008 to that in 2009?
Your response must be concise. 1.29. What is the ratio of the Expenses (in $) in Other expenses in 2008 to that in 2009?
Keep it short and to the point. 1.05. What is the ratio of the Expenses (in $) in Salary of employees in 2008 to that in 2010?
Ensure brevity in your answer.  0.76. What is the ratio of the Expenses (in $) of Custom duties in 2008 to that in 2010?
Provide a short and direct response. 0.78. What is the ratio of the Expenses (in $) in Interest Payments in 2008 to that in 2010?
Make the answer very short. 1.17. What is the ratio of the Expenses (in $) of Other expenses in 2008 to that in 2010?
Ensure brevity in your answer.  0.75. What is the ratio of the Expenses (in $) of Salary of employees in 2008 to that in 2011?
Give a very brief answer. 0.62. What is the ratio of the Expenses (in $) in Custom duties in 2008 to that in 2011?
Give a very brief answer. 0.74. What is the ratio of the Expenses (in $) in Interest Payments in 2008 to that in 2011?
Offer a terse response. 1.66. What is the ratio of the Expenses (in $) of Other expenses in 2008 to that in 2011?
Make the answer very short. 0.53. What is the ratio of the Expenses (in $) of Salary of employees in 2009 to that in 2010?
Offer a very short reply. 0.93. What is the ratio of the Expenses (in $) of Custom duties in 2009 to that in 2010?
Give a very brief answer. 1.04. What is the ratio of the Expenses (in $) in Interest Payments in 2009 to that in 2010?
Make the answer very short. 0.9. What is the ratio of the Expenses (in $) in Other expenses in 2009 to that in 2010?
Offer a terse response. 0.72. What is the ratio of the Expenses (in $) of Salary of employees in 2009 to that in 2011?
Your answer should be compact. 0.76. What is the ratio of the Expenses (in $) in Custom duties in 2009 to that in 2011?
Give a very brief answer. 0.98. What is the ratio of the Expenses (in $) of Interest Payments in 2009 to that in 2011?
Your answer should be compact. 1.29. What is the ratio of the Expenses (in $) in Other expenses in 2009 to that in 2011?
Your answer should be compact. 0.51. What is the ratio of the Expenses (in $) in Salary of employees in 2010 to that in 2011?
Offer a very short reply. 0.81. What is the ratio of the Expenses (in $) in Custom duties in 2010 to that in 2011?
Your answer should be very brief. 0.94. What is the ratio of the Expenses (in $) in Interest Payments in 2010 to that in 2011?
Keep it short and to the point. 1.42. What is the ratio of the Expenses (in $) in Other expenses in 2010 to that in 2011?
Your response must be concise. 0.71. What is the difference between the highest and the second highest Expenses (in $) in Salary of employees?
Make the answer very short. 1.63e+11. What is the difference between the highest and the second highest Expenses (in $) in Custom duties?
Ensure brevity in your answer.  2.95e+09. What is the difference between the highest and the second highest Expenses (in $) in Interest Payments?
Provide a succinct answer. 1.96e+1. What is the difference between the highest and the second highest Expenses (in $) of Other expenses?
Offer a very short reply. 8.25e+11. What is the difference between the highest and the lowest Expenses (in $) in Salary of employees?
Your response must be concise. 5.63e+11. What is the difference between the highest and the lowest Expenses (in $) in Custom duties?
Your response must be concise. 9.81e+1. What is the difference between the highest and the lowest Expenses (in $) of Interest Payments?
Keep it short and to the point. 1.25e+11. What is the difference between the highest and the lowest Expenses (in $) of Other expenses?
Provide a short and direct response. 2.00e+12. 